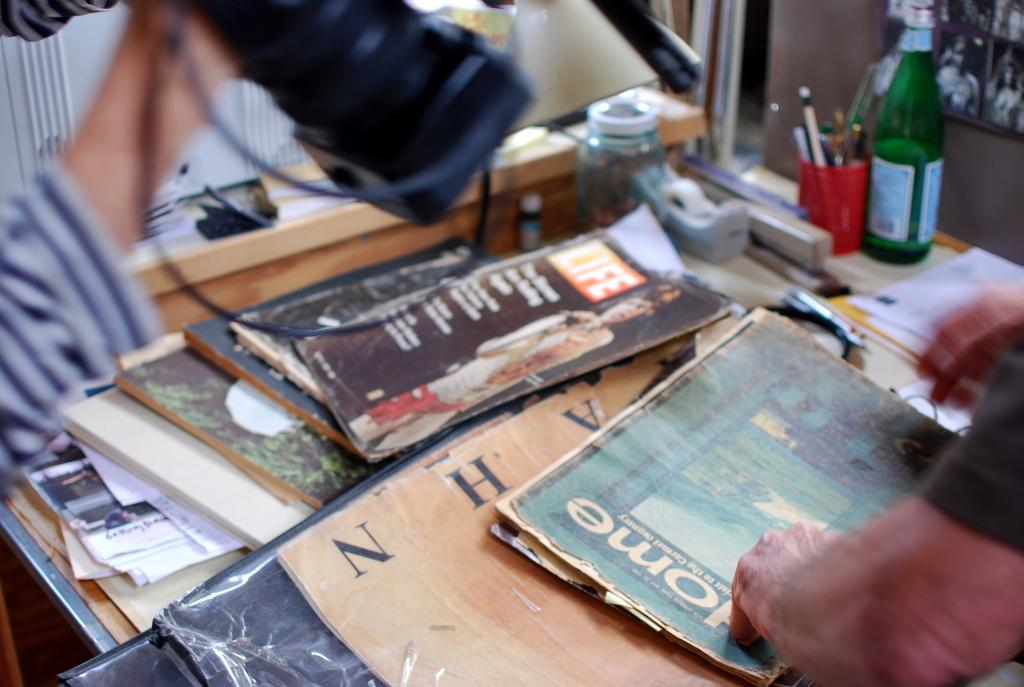Provide a one-sentence caption for the provided image. A man standing over a collection of magazines, one title Home. 